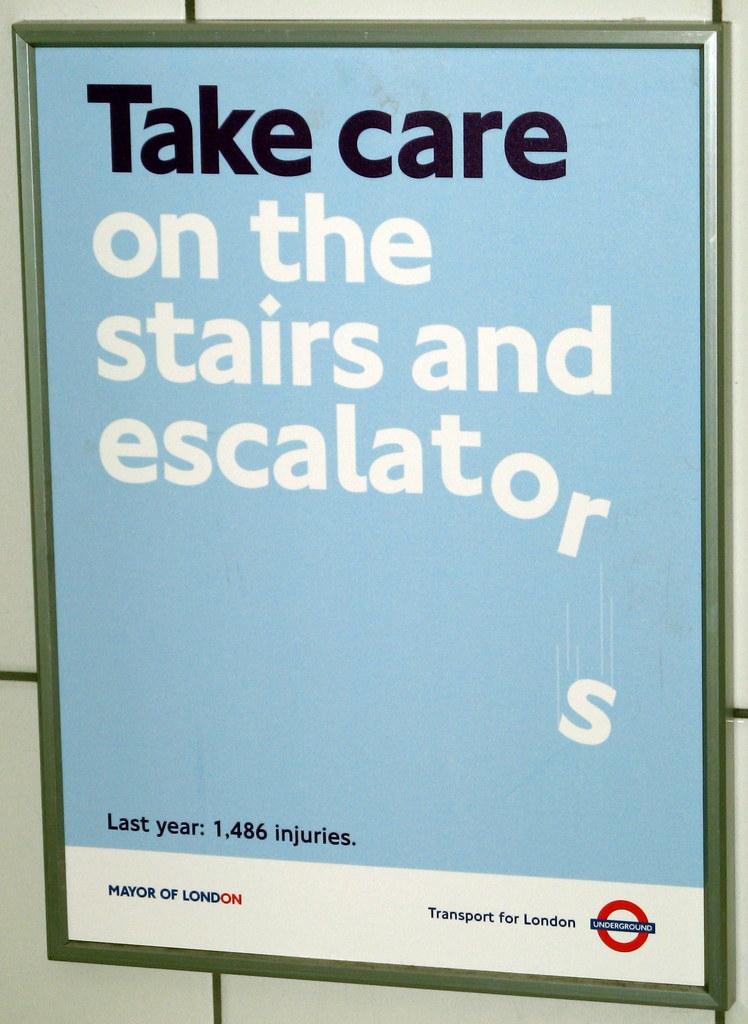How many injuries occured here last year?
Your response must be concise. 1486. What does this sign say?
Your answer should be very brief. Take care on the stairs and escalators. 